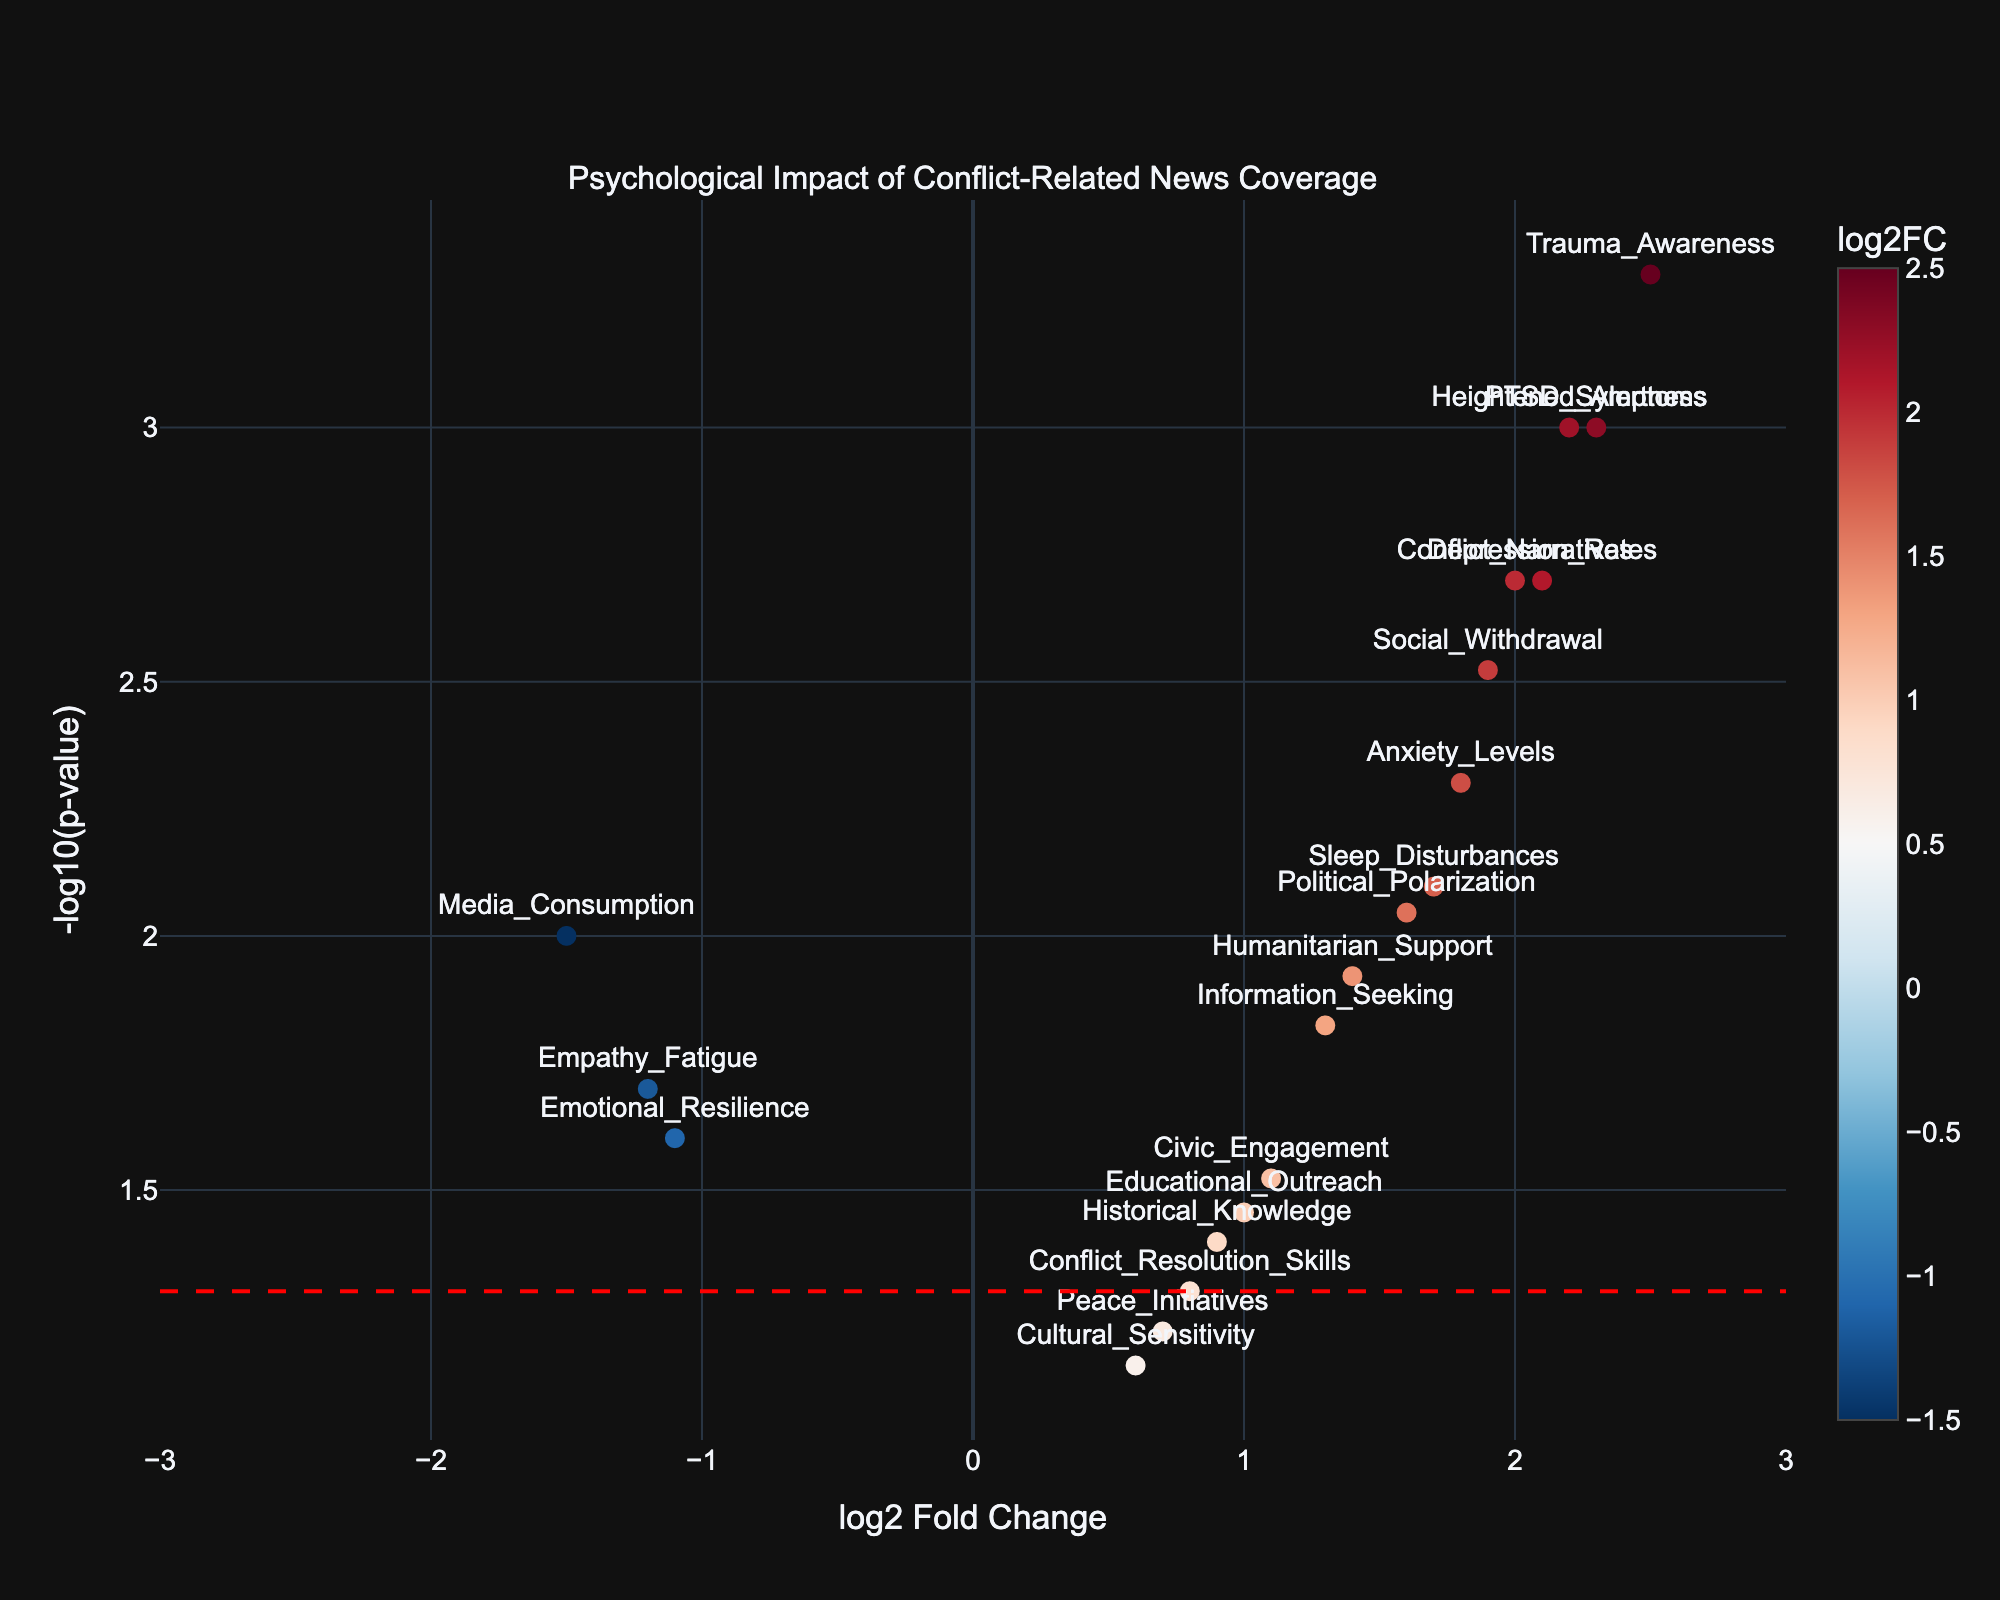what is the title of the plot? The title of the plot is always found at the top of the figure. In this case, the title is clearly stated above the plot area.
Answer: Psychological Impact of Conflict-Related News Coverage what is the range of the x-axis? The range of the x-axis is visible at the bottom of the plot, where it clearly extends from -3 to 3.
Answer: -3 to 3 How many data points fall above the significance threshold line? The significance threshold line is the horizontal red dashed line representing a p-value of 0.05. Count the number of points above this threshold line on the y-axis which corresponds to -log10(0.05). In the plot, there are 13 points above this line.
Answer: 13 which data point has the highest log2 fold change? The highest point on the x-axis in the plot is furthest to the right. Reading from the label, it corresponds to the data point "Trauma_Awareness" with a log2 fold change of 2.5.
Answer: Trauma_Awareness how are the negative log2 fold change values represented in color? Negative log2 fold change values are represented by the left color segment on the colorbar. In the figure, the color scale maps negative values to shades of blue according to the RdBu_r colorscale.
Answer: blue shades Which data points have a p-value below 0.005 and log2 fold change above 2? To find data points meeting these criteria, look at points above the y-axis value -log10(0.005) and to the right of x-axis value 2. The data points are "PTSD_Symptoms" and "Heightened_Alertness".
Answer: PTSD_Symptoms, Heightened_Alertness What is the log2 fold change and p-value for the "Conflict_Narratives" data point? Find "Conflict_Narratives" as labeled in the plot and use the hover text data, which shows log2 fold change and p-value. The log2 fold change is 2.0 and the p-value is 0.002.
Answer: log2 fold change 2.0 and p-value 0.002 Which data point has the highest -log10(p-value) but the lowest log2 fold change? The highest -log10(p-value) will be at the top of the y-axis. Among points highest on the y-axis, "Trauma_Awareness" has a -log10(p-value) of 3.3010 and appears furthest right along the x-axis (highest log2 fold change); however, we need the lowest log2 fold change. "PTSD_Symptoms" also has a high -log10(p-value) of 3.0000 but relatively lower log2 fold change.
Answer: PTSD_Symptoms 